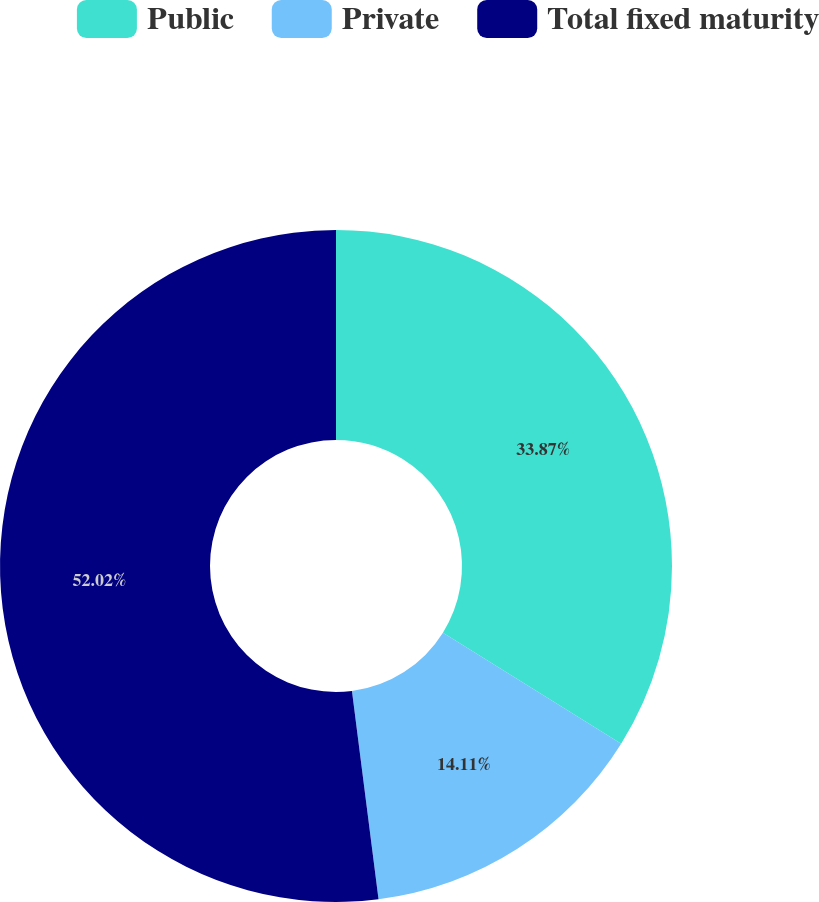Convert chart. <chart><loc_0><loc_0><loc_500><loc_500><pie_chart><fcel>Public<fcel>Private<fcel>Total fixed maturity<nl><fcel>33.87%<fcel>14.11%<fcel>52.02%<nl></chart> 